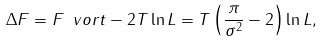<formula> <loc_0><loc_0><loc_500><loc_500>\Delta F = F _ { \ } v o r t - 2 T \ln L = T \left ( \frac { \pi } { \sigma ^ { 2 } } - 2 \right ) \ln L ,</formula> 